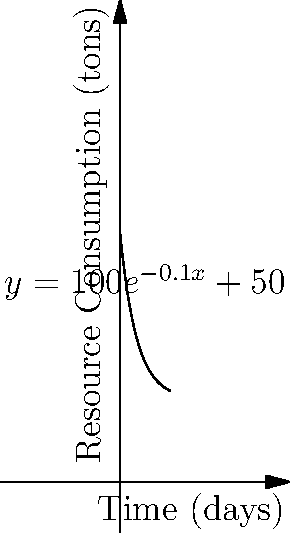During a prolonged siege, the daily resource consumption (in tons) of a besieged city is modeled by the function $y = 100e^{-0.1x} + 50$, where $x$ represents the number of days since the siege began. Calculate the total amount of resources consumed over the first 30 days of the siege. To find the total amount of resources consumed over 30 days, we need to calculate the area under the curve from $x=0$ to $x=30$. This can be done using a definite integral:

1) Set up the integral:
   $$\int_0^{30} (100e^{-0.1x} + 50) dx$$

2) Split the integral:
   $$\int_0^{30} 100e^{-0.1x} dx + \int_0^{30} 50 dx$$

3) Solve the first part:
   $$-1000e^{-0.1x}|_0^{30} = -1000(e^{-3} - 1)$$

4) Solve the second part:
   $$50x|_0^{30} = 1500$$

5) Sum the results:
   $$-1000(e^{-3} - 1) + 1500$$

6) Simplify:
   $$1000 - 1000e^{-3} + 1500 = 2500 - 1000e^{-3}$$

7) Calculate the final value:
   $$2500 - 1000 * 0.0497871 \approx 2450.21$$
Answer: 2450.21 tons 